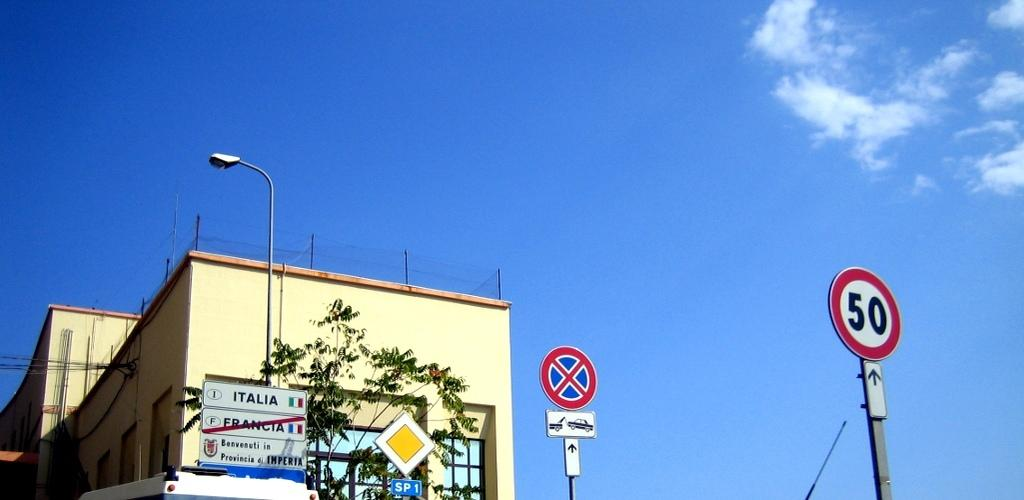What objects can be seen in the image that provide information or directions? There are sign boards in the image that provide information or directions. What is the tall, vertical object in the image? There is a pole in the image. What can be seen in the image that provides illumination? There is a light in the image. What type of man-made structure is visible in the image? There is a vehicle in the image. What can be seen in the background of the image that indicates the location or setting? There is a building, a tree, and clouds in the background of the image. What type of pies are being served on the furniture in the image? There is no mention of pies or furniture in the image; it features sign boards, a pole, a light, a vehicle, and a background with a building, a tree, and clouds. 